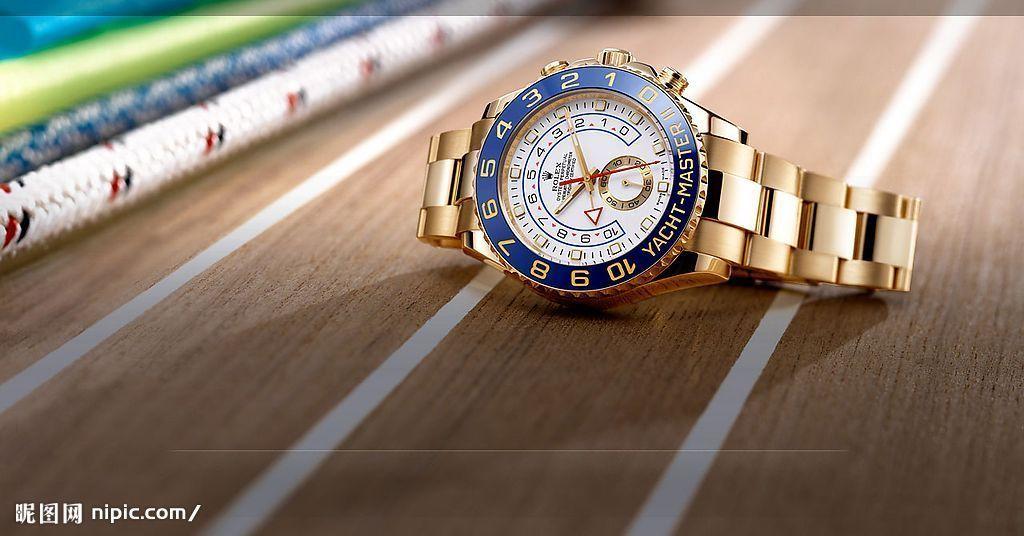What website does this picture come from?
Offer a very short reply. Nipic.com. What is the first word on the watch?
Make the answer very short. Yacht. 